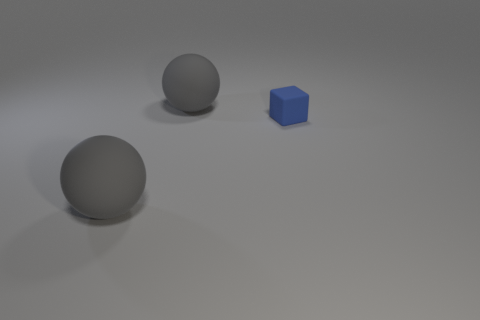Add 1 small objects. How many objects exist? 4 Subtract 2 balls. How many balls are left? 0 Subtract all red cubes. Subtract all purple cylinders. How many cubes are left? 1 Subtract all small gray cylinders. Subtract all rubber things. How many objects are left? 0 Add 1 gray things. How many gray things are left? 3 Add 1 small blue cubes. How many small blue cubes exist? 2 Subtract 0 green balls. How many objects are left? 3 Subtract all blocks. How many objects are left? 2 